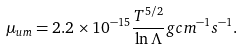<formula> <loc_0><loc_0><loc_500><loc_500>\mu _ { u m } = 2 . 2 \times 1 0 ^ { - 1 5 } \frac { T ^ { 5 / 2 } } { \ln \Lambda } g c m ^ { - 1 } s ^ { - 1 } .</formula> 